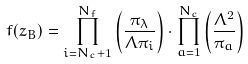<formula> <loc_0><loc_0><loc_500><loc_500>f ( z _ { B } ) = \prod _ { i = N _ { c } + 1 } ^ { N _ { f } } \left ( \frac { \pi _ { \lambda } } { \Lambda \pi _ { i } } \right ) \cdot \prod _ { a = 1 } ^ { N _ { c } } \left ( \frac { \Lambda ^ { 2 } } { \pi _ { a } } \right )</formula> 